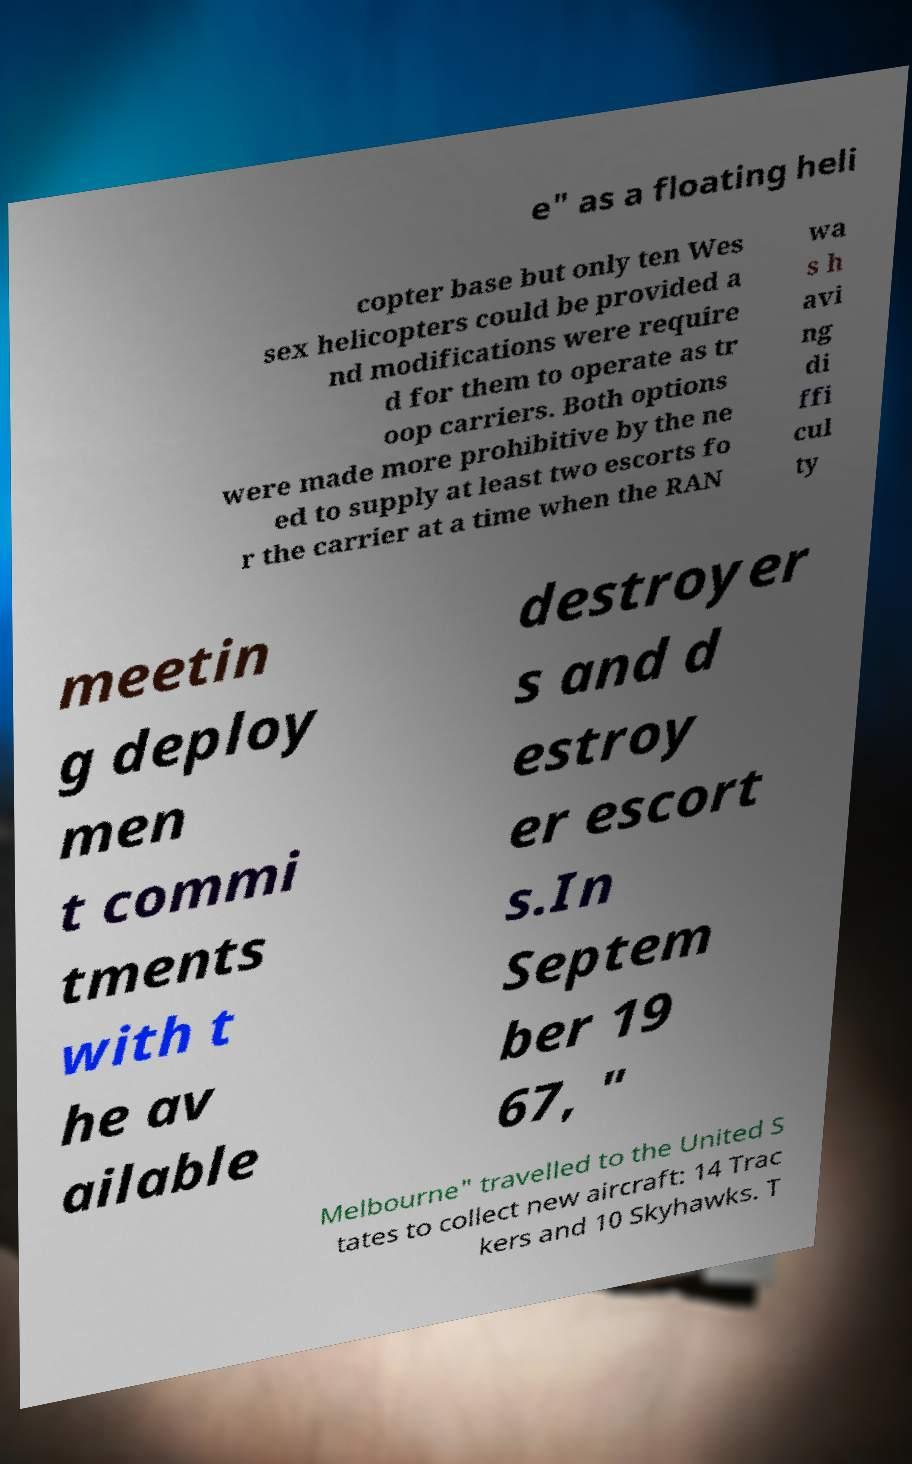For documentation purposes, I need the text within this image transcribed. Could you provide that? e" as a floating heli copter base but only ten Wes sex helicopters could be provided a nd modifications were require d for them to operate as tr oop carriers. Both options were made more prohibitive by the ne ed to supply at least two escorts fo r the carrier at a time when the RAN wa s h avi ng di ffi cul ty meetin g deploy men t commi tments with t he av ailable destroyer s and d estroy er escort s.In Septem ber 19 67, " Melbourne" travelled to the United S tates to collect new aircraft: 14 Trac kers and 10 Skyhawks. T 